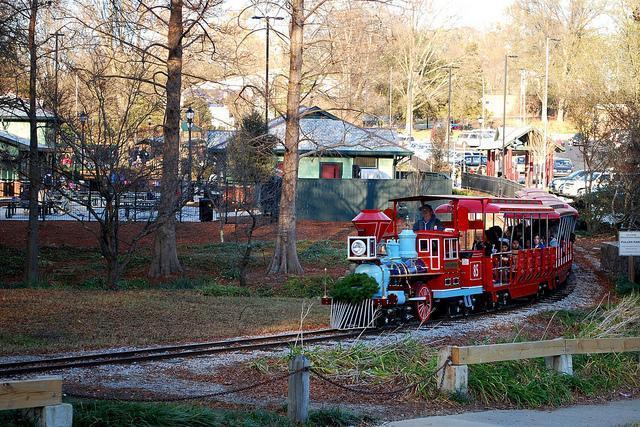How many zebras are shown?
Give a very brief answer. 0. 